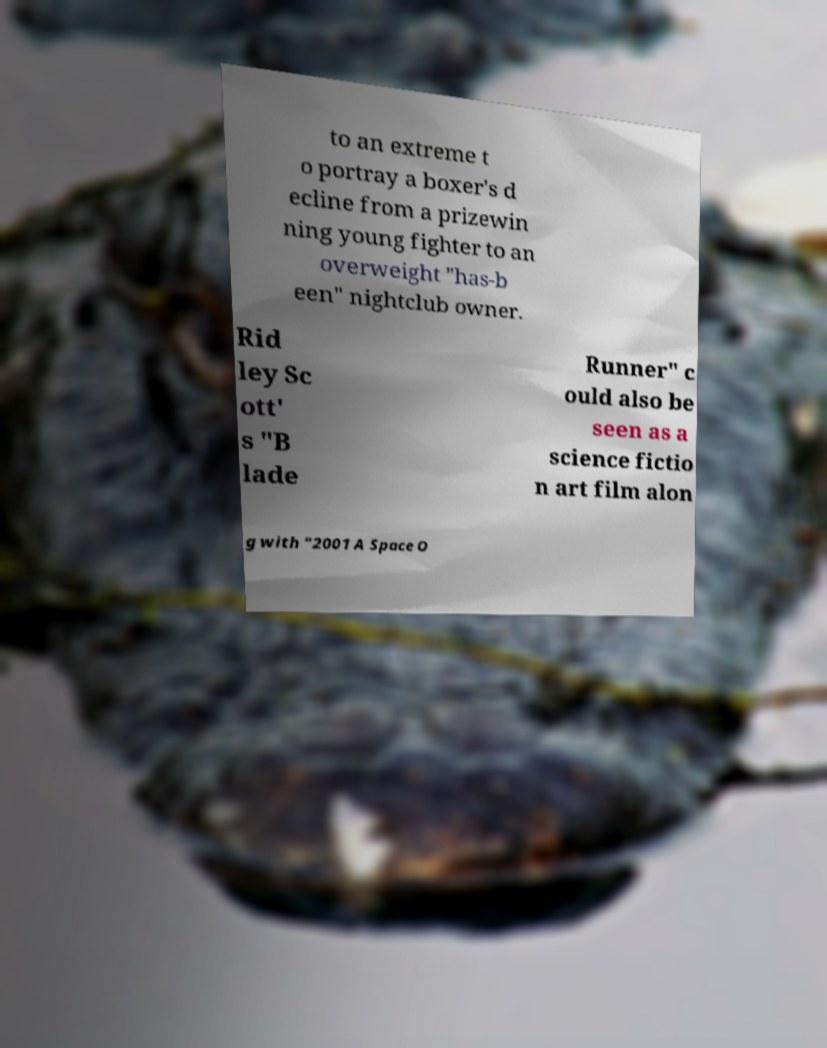Please identify and transcribe the text found in this image. to an extreme t o portray a boxer's d ecline from a prizewin ning young fighter to an overweight "has-b een" nightclub owner. Rid ley Sc ott' s "B lade Runner" c ould also be seen as a science fictio n art film alon g with "2001 A Space O 